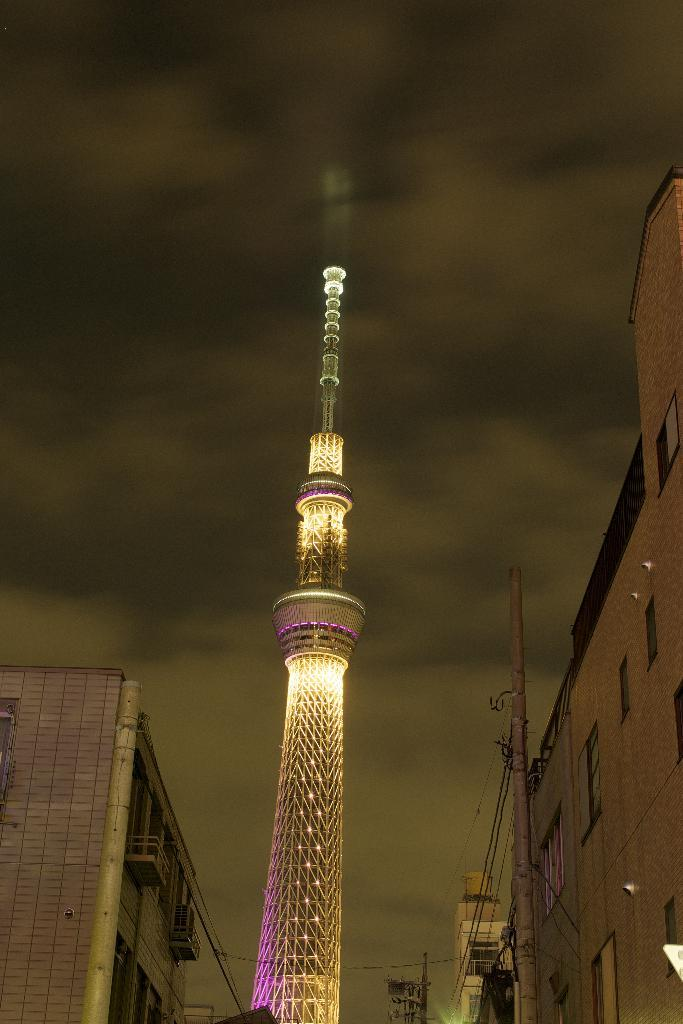What type of structures can be seen in the image? There are buildings in the image. What feature is common to many of the buildings? There are windows in the buildings. What are the poles and wires used for in the image? The poles and wires are likely used for supporting and transmitting electrical or communication lines. What is the tallest structure in the image? There is a tower in the image. How is the sky depicted in the image? The sky is in white and black color. What type of hook can be seen on the tower in the image? There is no hook visible on the tower in the image. What type of blade is being used for digestion in the image? There is no blade or digestion process depicted in the image. 